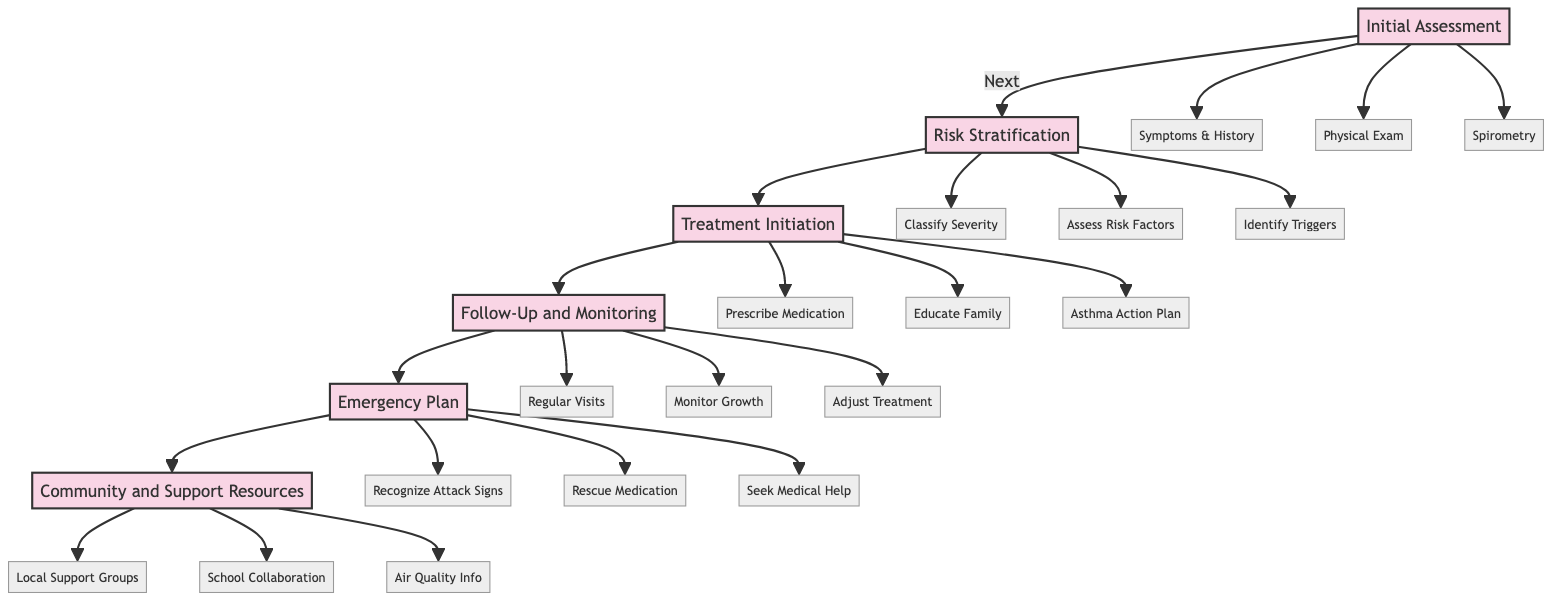What is the first step in the clinical pathway? The diagram clearly indicates the first step is labeled as "Initial Assessment," which is the starting point of the Pediatric Asthma Management pathway.
Answer: Initial Assessment How many main steps are there in the clinical pathway? By counting the nodes in the diagram, we can see there are six main steps: Initial Assessment, Risk Stratification, Treatment Initiation, Follow-Up and Monitoring, Emergency Plan, and Community and Support Resources.
Answer: Six What follows after the Treatment Initiation step? Following the Treatment Initiation step, the subsequent step in the pathway is Follow-Up and Monitoring, as indicated by the arrows connecting the steps.
Answer: Follow-Up and Monitoring Which step includes recognizing signs of an asthma attack? The Emergency Plan step specifically includes recognizing signs of an asthma attack, as detailed in the sub-steps underneath it.
Answer: Emergency Plan What action is recommended in the Follow-Up and Monitoring step? One of the actions recommended in the Follow-Up and Monitoring step is to schedule regular follow-up visits, ensuring continuous care for the patient.
Answer: Schedule regular follow-up visits In which step is the Asthma Action Plan developed? The step where the Asthma Action Plan is developed is the Treatment Initiation step, as mentioned under its details.
Answer: Treatment Initiation How many sub-details are mentioned under the Risk Stratification step? Under the Risk Stratification step, there are three sub-details listed: classify severity, assess risk factors, and identify triggers, making a total of three sub-details.
Answer: Three What community resource is mentioned in the Community and Support Resources step? The Community and Support Resources step mentions referring to local support groups, specifically the Wiggins Asthma Support Group, as a valuable resource for families.
Answer: Local Support Groups 